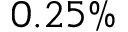Convert formula to latex. <formula><loc_0><loc_0><loc_500><loc_500>0 . 2 5 \%</formula> 